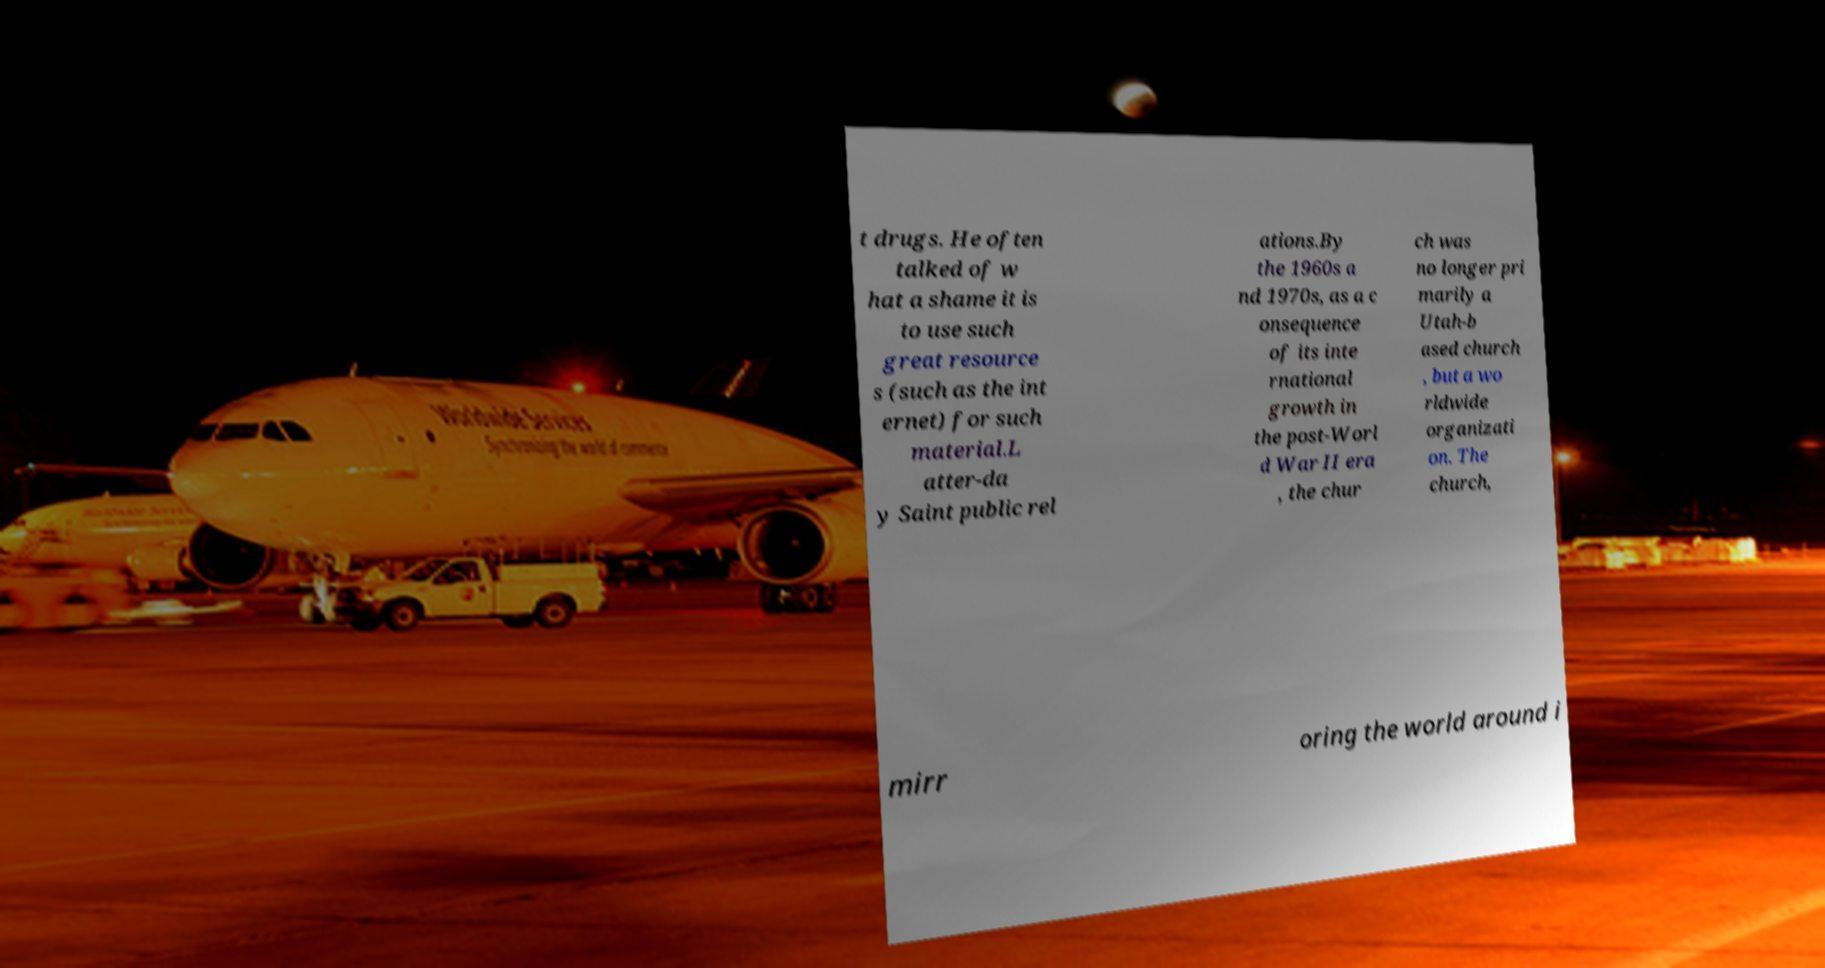Can you read and provide the text displayed in the image?This photo seems to have some interesting text. Can you extract and type it out for me? t drugs. He often talked of w hat a shame it is to use such great resource s (such as the int ernet) for such material.L atter-da y Saint public rel ations.By the 1960s a nd 1970s, as a c onsequence of its inte rnational growth in the post-Worl d War II era , the chur ch was no longer pri marily a Utah-b ased church , but a wo rldwide organizati on. The church, mirr oring the world around i 